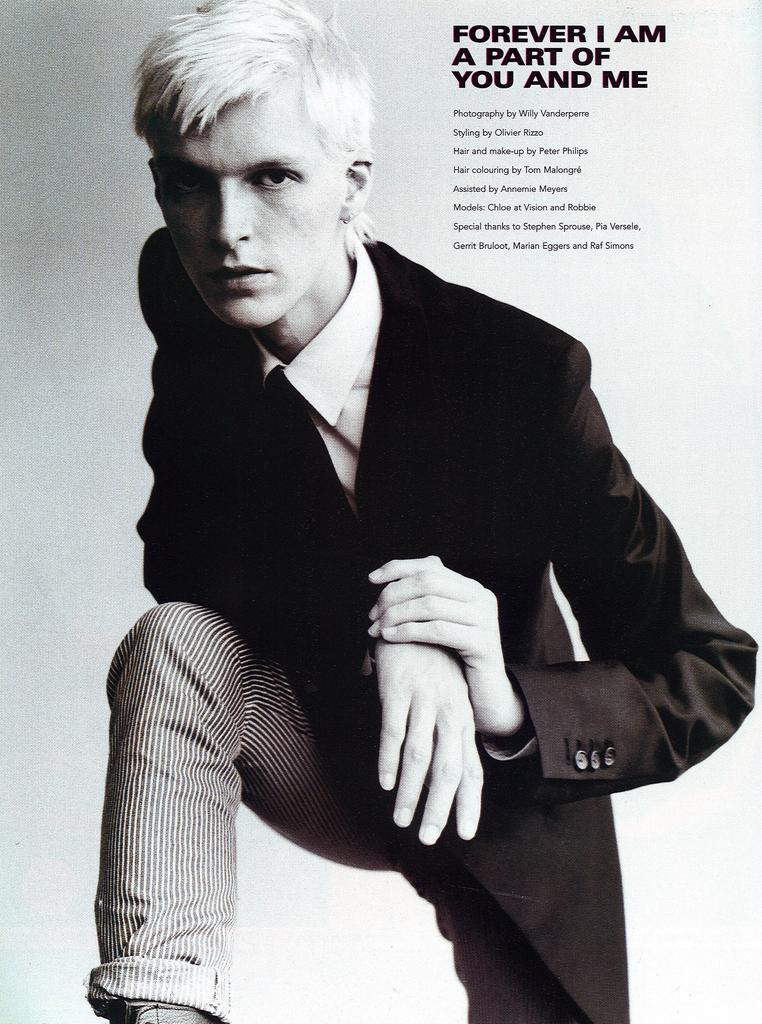What is the main subject of the image? There is a person in the image. Can you describe the person's appearance? The person is wearing clothes. What else can be seen in the image? There is text in the top right of the image. What invention is the person using in the image? There is no invention visible in the image; it only shows a person wearing clothes and text in the top right corner. What type of experience is the person having in the image? The image does not provide enough information to determine the person's experience. 